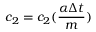Convert formula to latex. <formula><loc_0><loc_0><loc_500><loc_500>c _ { 2 } = c _ { 2 } ( \frac { \alpha \Delta { t } } { m } )</formula> 